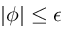Convert formula to latex. <formula><loc_0><loc_0><loc_500><loc_500>| \phi | \leq \epsilon</formula> 